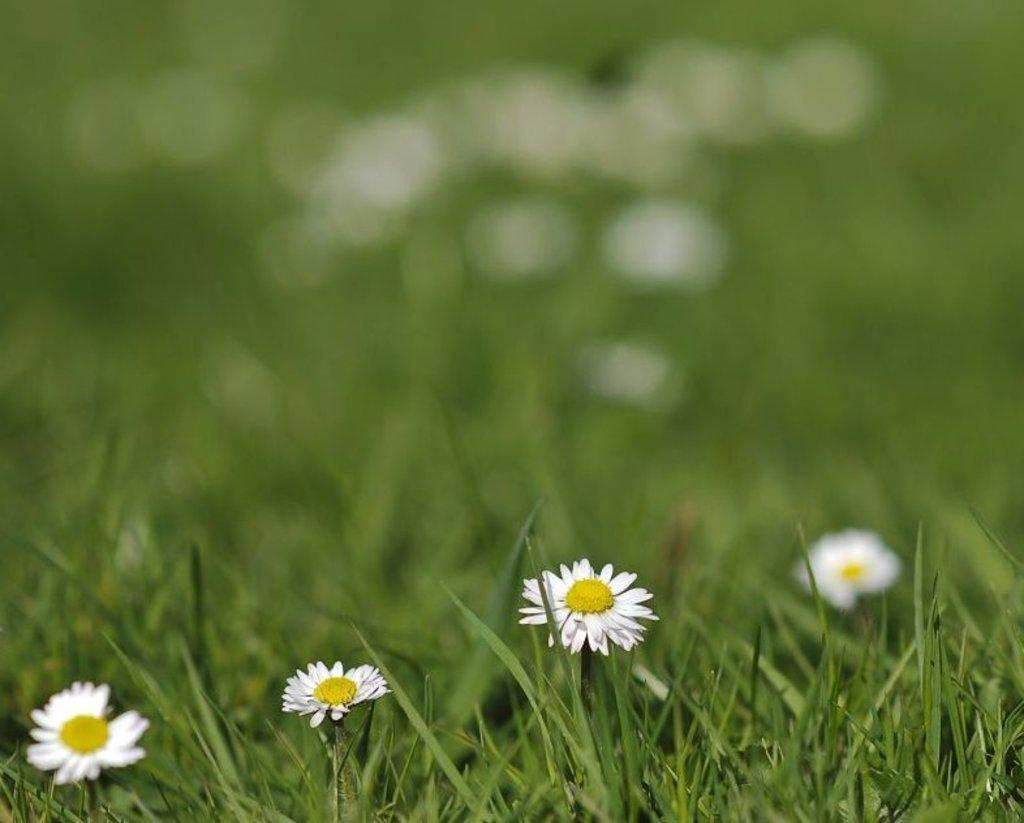Describe this image in one or two sentences. In this image we can see four flowers. In the foreground we can see grass. 